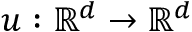<formula> <loc_0><loc_0><loc_500><loc_500>u \colon \mathbb { R } ^ { d } \rightarrow \mathbb { R } ^ { d }</formula> 